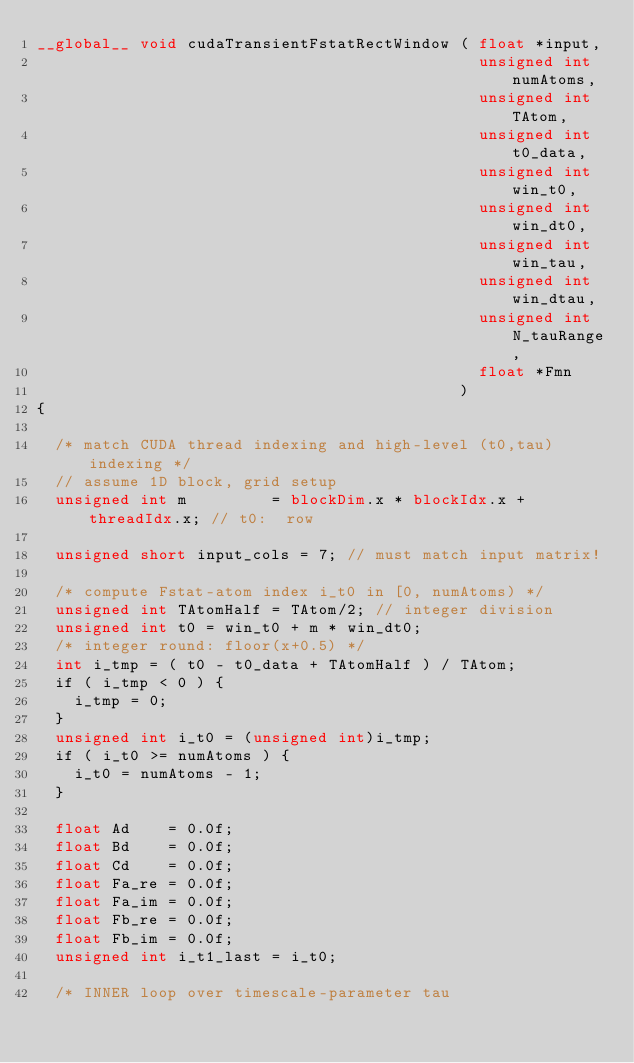<code> <loc_0><loc_0><loc_500><loc_500><_Cuda_>__global__ void cudaTransientFstatRectWindow ( float *input,
                                               unsigned int numAtoms,
                                               unsigned int TAtom,
                                               unsigned int t0_data,
                                               unsigned int win_t0,
                                               unsigned int win_dt0,
                                               unsigned int win_tau,
                                               unsigned int win_dtau,
                                               unsigned int N_tauRange,
                                               float *Fmn
                                             )
{

  /* match CUDA thread indexing and high-level (t0,tau) indexing */
  // assume 1D block, grid setup
  unsigned int m         = blockDim.x * blockIdx.x + threadIdx.x; // t0:  row

  unsigned short input_cols = 7; // must match input matrix!

  /* compute Fstat-atom index i_t0 in [0, numAtoms) */
  unsigned int TAtomHalf = TAtom/2; // integer division
  unsigned int t0 = win_t0 + m * win_dt0;
  /* integer round: floor(x+0.5) */
  int i_tmp = ( t0 - t0_data + TAtomHalf ) / TAtom;
  if ( i_tmp < 0 ) {
    i_tmp = 0;
  }
  unsigned int i_t0 = (unsigned int)i_tmp;
  if ( i_t0 >= numAtoms ) {
    i_t0 = numAtoms - 1;
  }

  float Ad    = 0.0f;
  float Bd    = 0.0f;
  float Cd    = 0.0f;
  float Fa_re = 0.0f;
  float Fa_im = 0.0f;
  float Fb_re = 0.0f;
  float Fb_im = 0.0f;
  unsigned int i_t1_last = i_t0;

  /* INNER loop over timescale-parameter tau</code> 